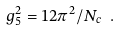Convert formula to latex. <formula><loc_0><loc_0><loc_500><loc_500>g _ { 5 } ^ { 2 } = 1 2 \pi ^ { 2 } / N _ { c } \ .</formula> 